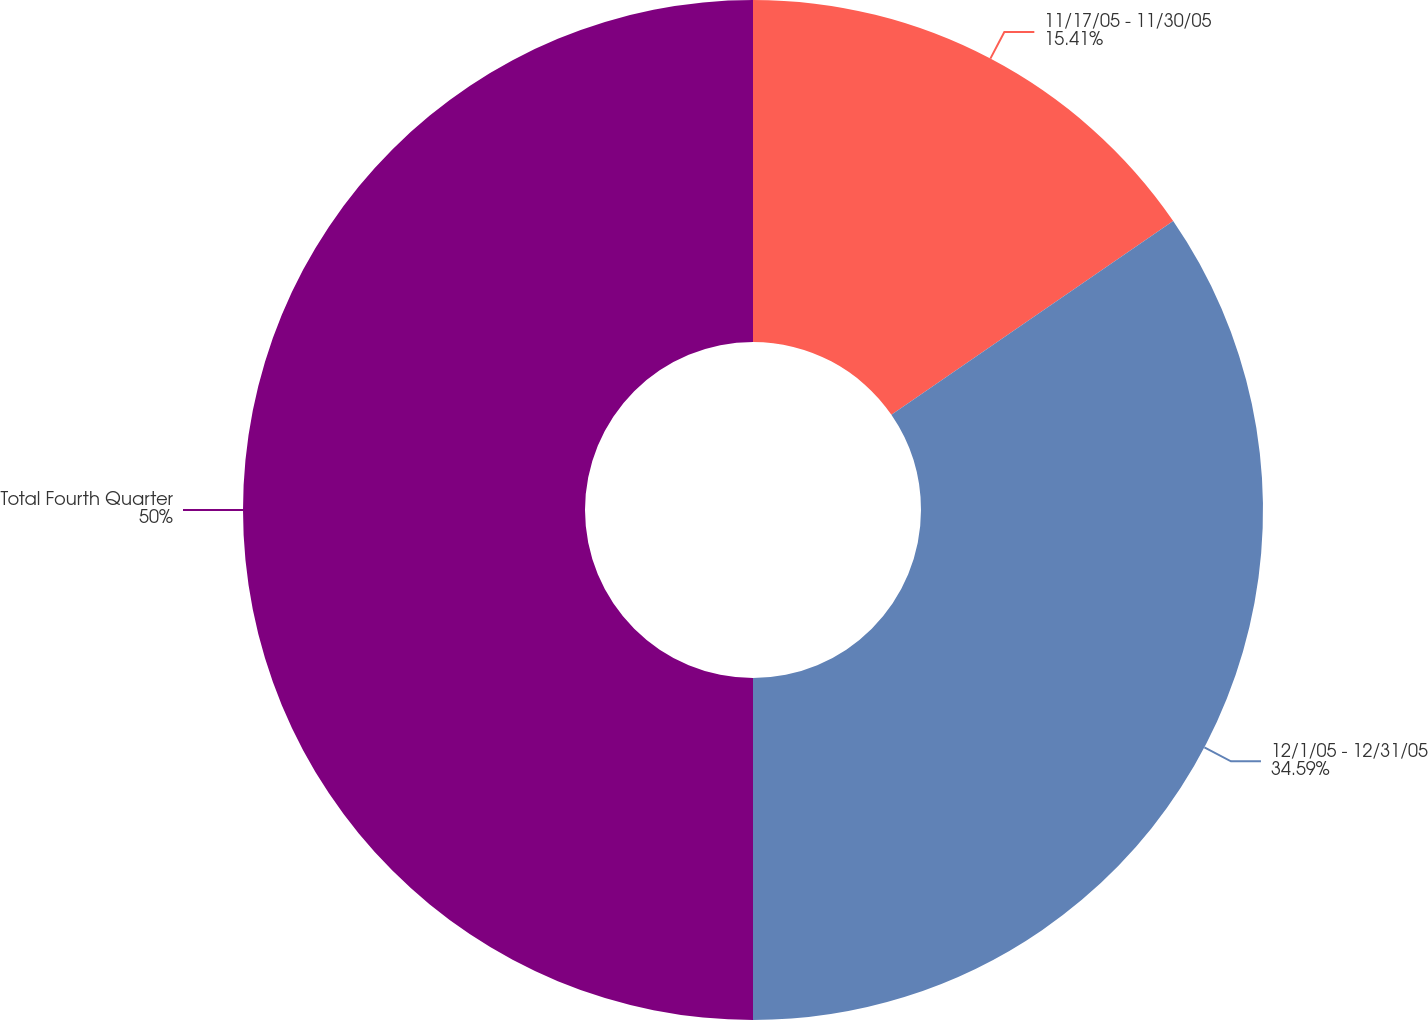<chart> <loc_0><loc_0><loc_500><loc_500><pie_chart><fcel>11/17/05 - 11/30/05<fcel>12/1/05 - 12/31/05<fcel>Total Fourth Quarter<nl><fcel>15.41%<fcel>34.59%<fcel>50.0%<nl></chart> 